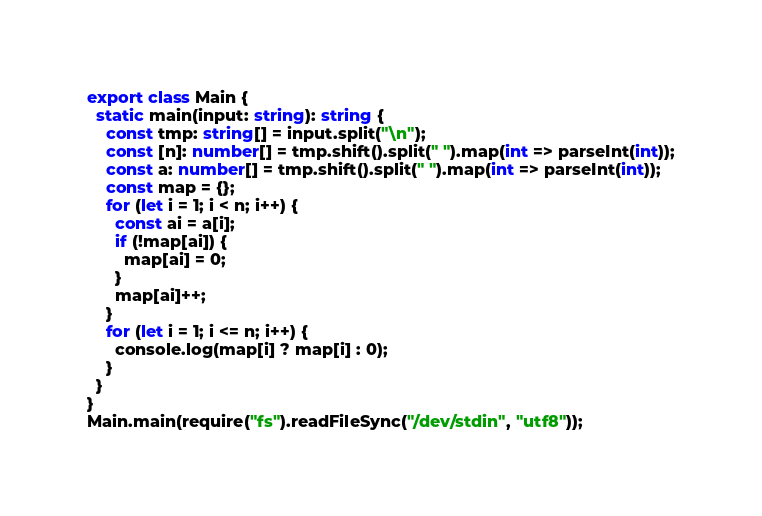<code> <loc_0><loc_0><loc_500><loc_500><_TypeScript_>export class Main {
  static main(input: string): string {
    const tmp: string[] = input.split("\n");
    const [n]: number[] = tmp.shift().split(" ").map(int => parseInt(int));
    const a: number[] = tmp.shift().split(" ").map(int => parseInt(int));
    const map = {};
    for (let i = 1; i < n; i++) {
      const ai = a[i];
      if (!map[ai]) {
        map[ai] = 0;
      }
      map[ai]++;
    }
    for (let i = 1; i <= n; i++) {
      console.log(map[i] ? map[i] : 0);
    }
  }
}
Main.main(require("fs").readFileSync("/dev/stdin", "utf8"));
</code> 